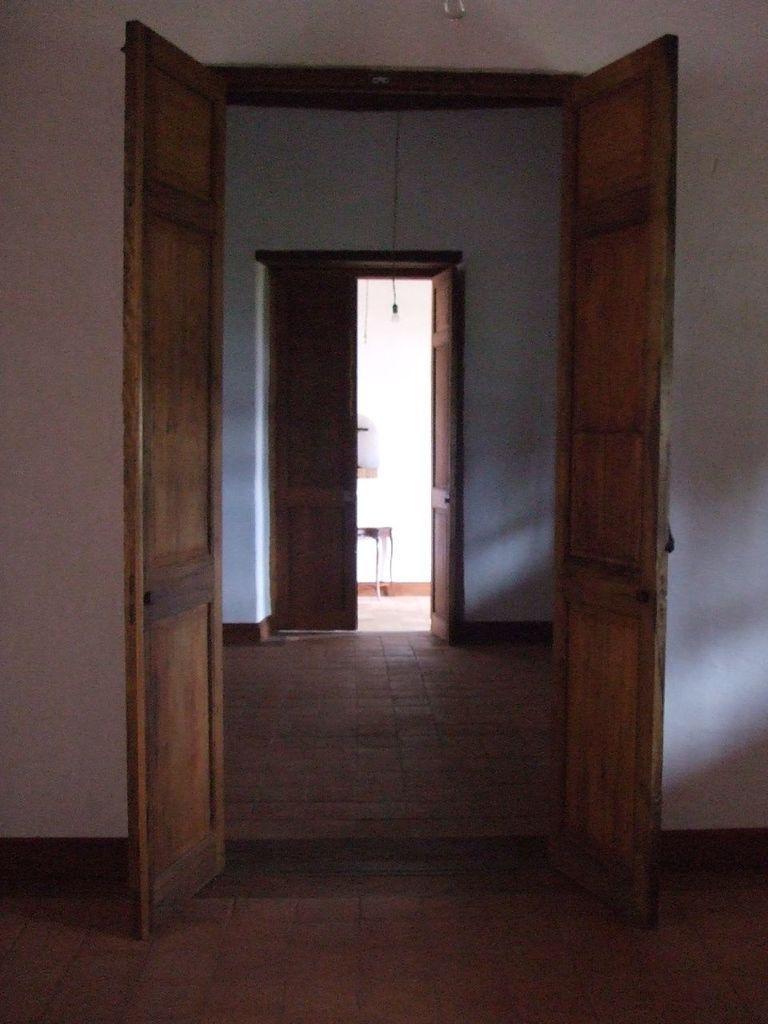Can you describe this image briefly? There are rooms having wooden doors and white walls. In the background, there is a table near white wall. 